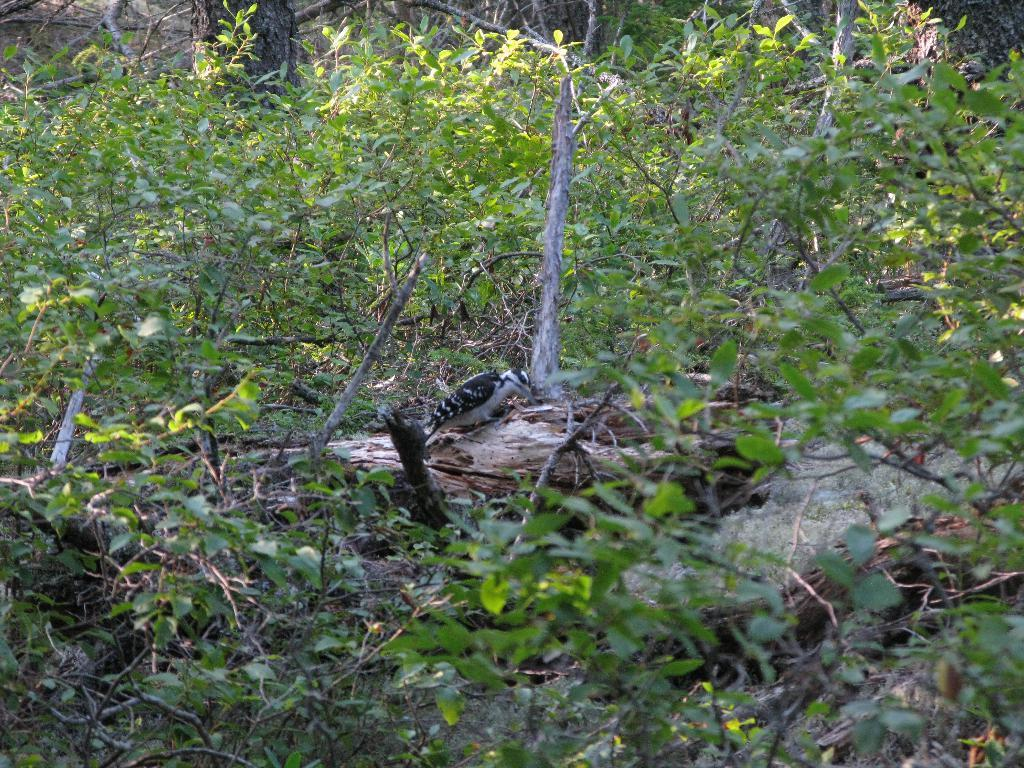What type of animal can be seen in the image? There is a bird in the image. Where is the bird located? The bird is on a broken tree pole. What else is visible near the tree pole? There are plants beside the tree pole. Can you tell me how many appliances are visible in the image? There are no appliances present in the image; it features a bird on a broken tree pole with plants nearby. 